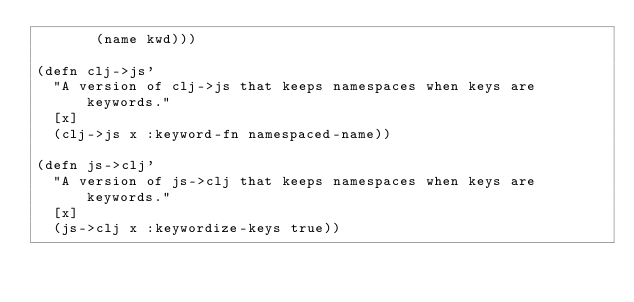Convert code to text. <code><loc_0><loc_0><loc_500><loc_500><_Clojure_>       (name kwd)))

(defn clj->js'
  "A version of clj->js that keeps namespaces when keys are keywords."
  [x]
  (clj->js x :keyword-fn namespaced-name))

(defn js->clj'
  "A version of js->clj that keeps namespaces when keys are keywords."
  [x]
  (js->clj x :keywordize-keys true))
</code> 